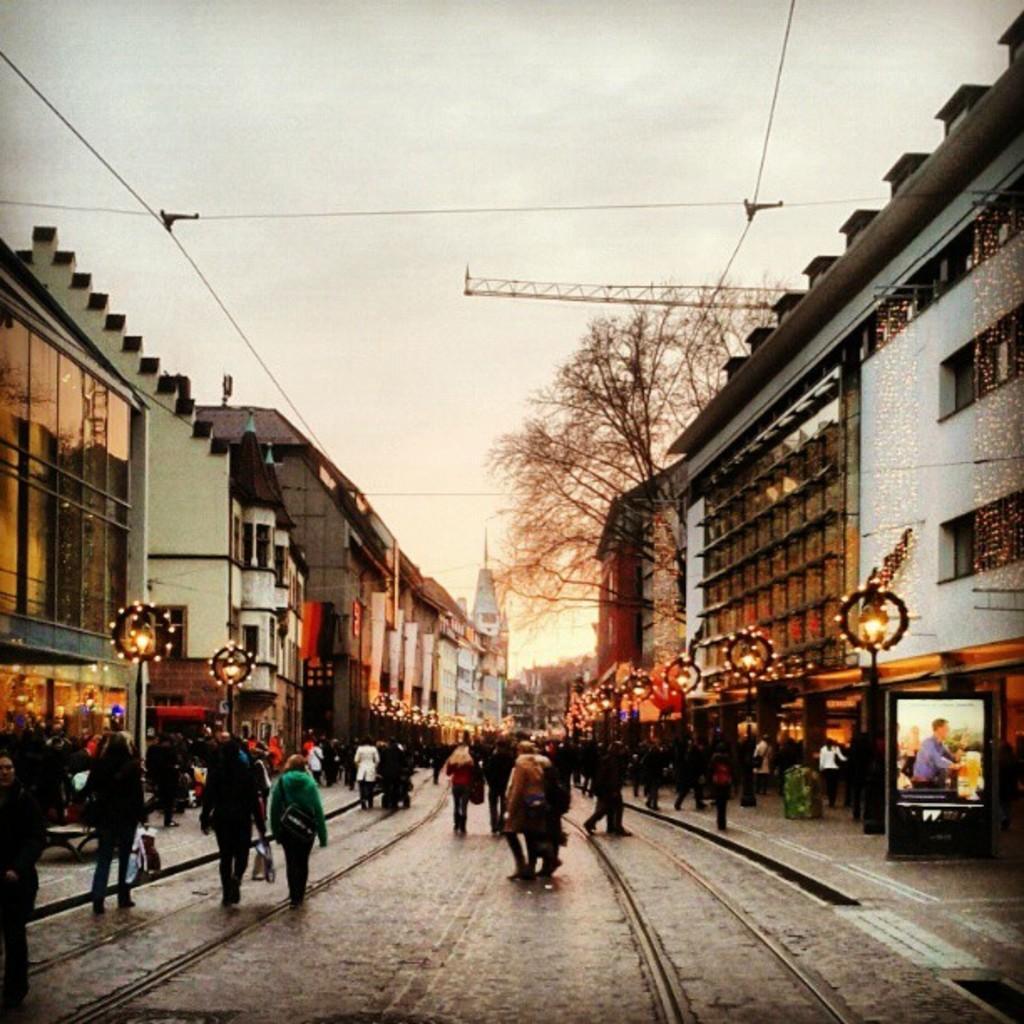Describe this image in one or two sentences. This image is taken outdoors. At the bottom of the image there is a road and there is a sidewalk. At the top of the image there is a sky with clouds and there are a few wires and an iron bar. In the middle of the image many people are walking on the road. On the left and right sides of the image there are a few buildings and decorated with lights and lamps. There are a few street lights and there is a tree. On the right side of the image there is a board. 